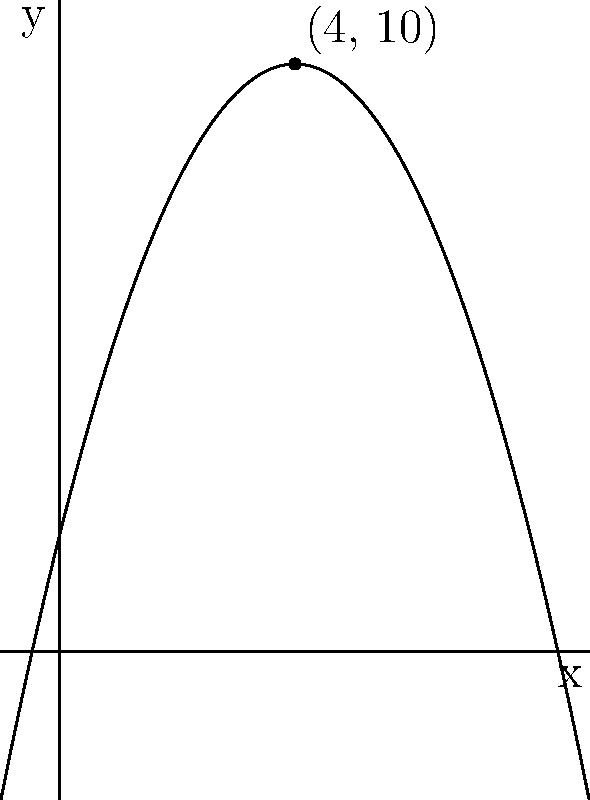Considere uma estratégia de staking em um protocolo DeFi representada pela função de recompensa $f(x) = -0.5x^2 + 4x + 2$, onde $x$ é o tempo de staking em meses e $f(x)$ é a recompensa em tokens. Qual é o tempo de staking ótimo para maximizar a recompensa e qual é o valor máximo da recompensa? Para encontrar o ponto máximo da função quadrática $f(x) = -0.5x^2 + 4x + 2$, seguimos estes passos:

1) Calcular a derivada da função: $f'(x) = -x + 4$

2) Igualar a derivada a zero para encontrar o ponto crítico:
   $-x + 4 = 0$
   $x = 4$

3) Como o coeficiente de $x^2$ é negativo (-0.5), sabemos que este ponto crítico é um máximo.

4) Para encontrar o valor máximo da recompensa, substituímos $x = 4$ na função original:
   $f(4) = -0.5(4)^2 + 4(4) + 2$
   $     = -8 + 16 + 2$
   $     = 10$

Portanto, o tempo de staking ótimo é 4 meses, e a recompensa máxima é de 10 tokens.
Answer: Tempo ótimo: 4 meses; Recompensa máxima: 10 tokens 